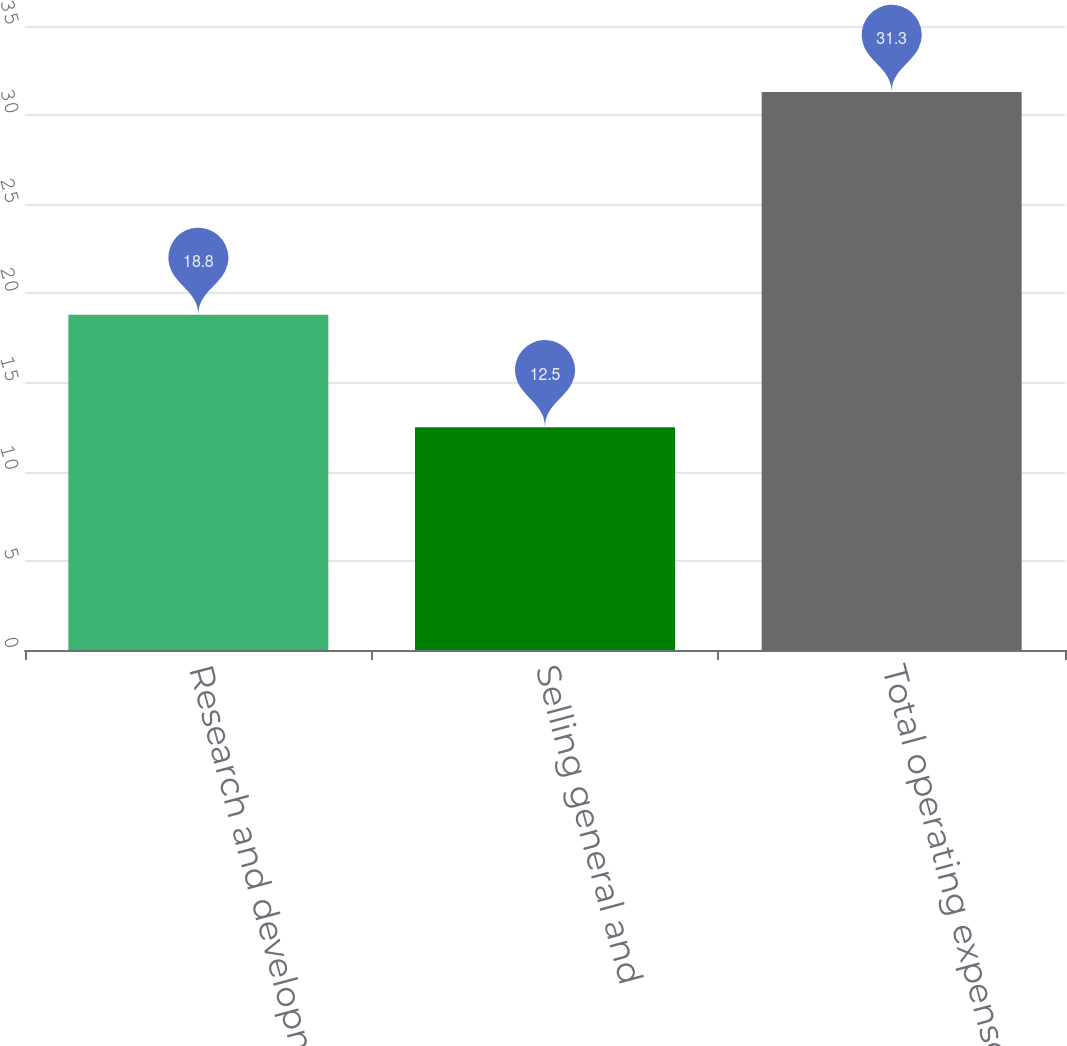Convert chart. <chart><loc_0><loc_0><loc_500><loc_500><bar_chart><fcel>Research and development<fcel>Selling general and<fcel>Total operating expenses<nl><fcel>18.8<fcel>12.5<fcel>31.3<nl></chart> 